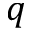Convert formula to latex. <formula><loc_0><loc_0><loc_500><loc_500>q</formula> 